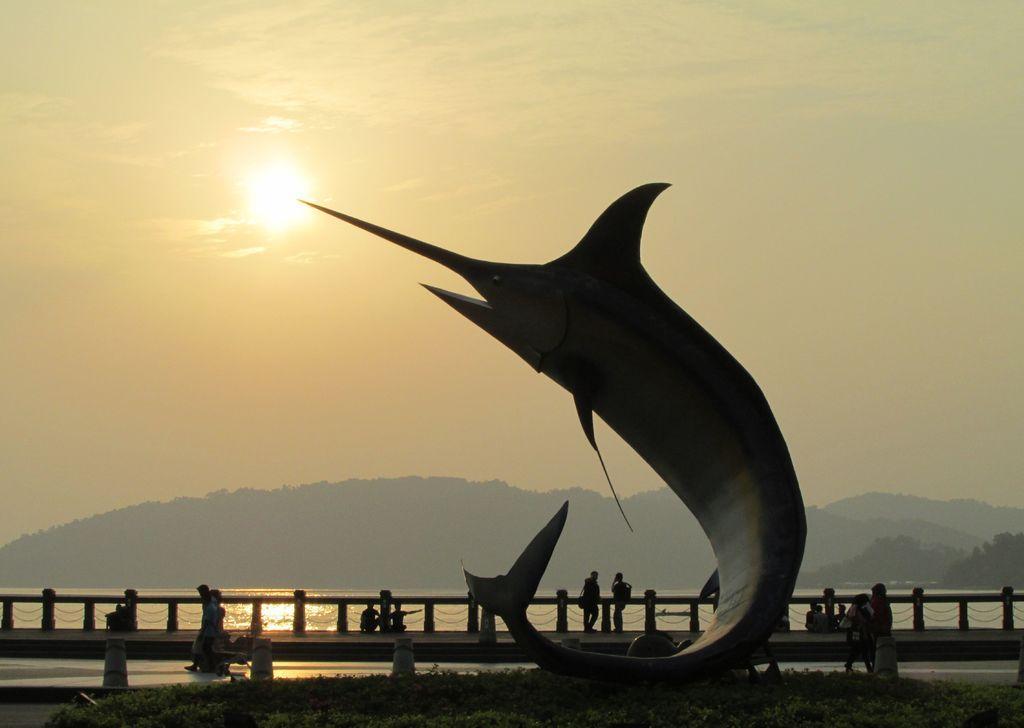In one or two sentences, can you explain what this image depicts? In the center of the image there is a depiction of a fish. There is a bridge on which there are people. At the bottom of the image there are plants. In the background of the image there are mountains, sky and sun. There is water. 